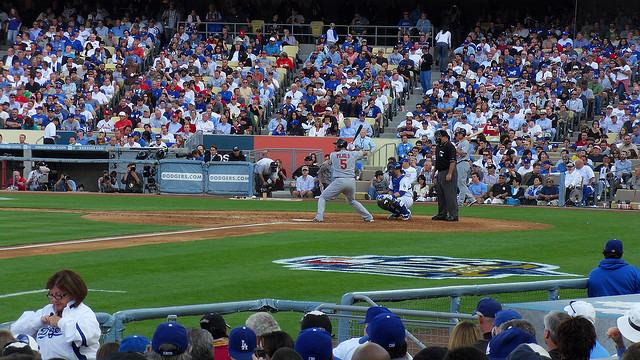Is this a well attended game?
Quick response, please. Yes. Is the stadium full?
Quick response, please. Yes. Does this landscape take a lot of maintenance to stay this sharp?
Short answer required. Yes. How many people are in this picture?
Quick response, please. Hundreds. 